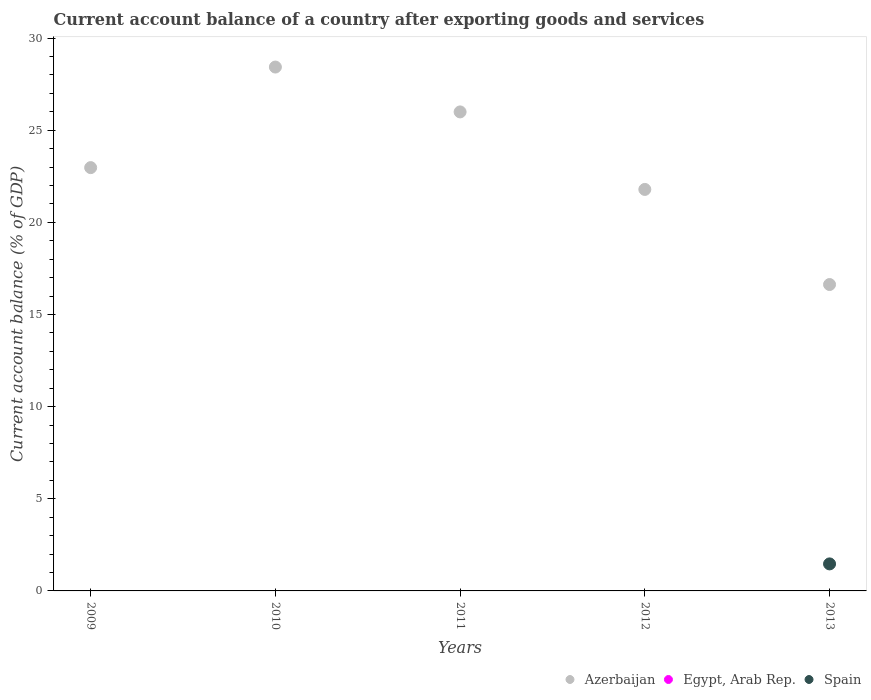What is the account balance in Egypt, Arab Rep. in 2009?
Offer a very short reply. 0. Across all years, what is the maximum account balance in Spain?
Ensure brevity in your answer.  1.47. In which year was the account balance in Spain maximum?
Keep it short and to the point. 2013. What is the total account balance in Spain in the graph?
Your answer should be very brief. 1.47. What is the difference between the account balance in Azerbaijan in 2011 and that in 2012?
Make the answer very short. 4.21. What is the average account balance in Azerbaijan per year?
Provide a succinct answer. 23.16. In the year 2013, what is the difference between the account balance in Spain and account balance in Azerbaijan?
Your answer should be compact. -15.16. In how many years, is the account balance in Egypt, Arab Rep. greater than 20 %?
Ensure brevity in your answer.  0. What is the ratio of the account balance in Azerbaijan in 2009 to that in 2010?
Provide a succinct answer. 0.81. What is the difference between the highest and the second highest account balance in Azerbaijan?
Provide a succinct answer. 2.43. What is the difference between the highest and the lowest account balance in Azerbaijan?
Your answer should be very brief. 11.8. In how many years, is the account balance in Azerbaijan greater than the average account balance in Azerbaijan taken over all years?
Offer a very short reply. 2. How many dotlines are there?
Your response must be concise. 2. How many years are there in the graph?
Offer a very short reply. 5. Are the values on the major ticks of Y-axis written in scientific E-notation?
Make the answer very short. No. Does the graph contain any zero values?
Ensure brevity in your answer.  Yes. Where does the legend appear in the graph?
Your answer should be very brief. Bottom right. How many legend labels are there?
Your answer should be compact. 3. What is the title of the graph?
Offer a very short reply. Current account balance of a country after exporting goods and services. Does "Belgium" appear as one of the legend labels in the graph?
Make the answer very short. No. What is the label or title of the X-axis?
Provide a short and direct response. Years. What is the label or title of the Y-axis?
Make the answer very short. Current account balance (% of GDP). What is the Current account balance (% of GDP) in Azerbaijan in 2009?
Your answer should be compact. 22.97. What is the Current account balance (% of GDP) of Spain in 2009?
Provide a succinct answer. 0. What is the Current account balance (% of GDP) in Azerbaijan in 2010?
Offer a terse response. 28.43. What is the Current account balance (% of GDP) of Azerbaijan in 2011?
Give a very brief answer. 26. What is the Current account balance (% of GDP) of Egypt, Arab Rep. in 2011?
Offer a very short reply. 0. What is the Current account balance (% of GDP) of Azerbaijan in 2012?
Give a very brief answer. 21.79. What is the Current account balance (% of GDP) of Azerbaijan in 2013?
Offer a very short reply. 16.63. What is the Current account balance (% of GDP) in Egypt, Arab Rep. in 2013?
Provide a short and direct response. 0. What is the Current account balance (% of GDP) in Spain in 2013?
Keep it short and to the point. 1.47. Across all years, what is the maximum Current account balance (% of GDP) in Azerbaijan?
Make the answer very short. 28.43. Across all years, what is the maximum Current account balance (% of GDP) in Spain?
Give a very brief answer. 1.47. Across all years, what is the minimum Current account balance (% of GDP) in Azerbaijan?
Your answer should be compact. 16.63. Across all years, what is the minimum Current account balance (% of GDP) of Spain?
Your answer should be very brief. 0. What is the total Current account balance (% of GDP) in Azerbaijan in the graph?
Your response must be concise. 115.82. What is the total Current account balance (% of GDP) in Egypt, Arab Rep. in the graph?
Your answer should be very brief. 0. What is the total Current account balance (% of GDP) of Spain in the graph?
Offer a terse response. 1.47. What is the difference between the Current account balance (% of GDP) of Azerbaijan in 2009 and that in 2010?
Offer a terse response. -5.46. What is the difference between the Current account balance (% of GDP) of Azerbaijan in 2009 and that in 2011?
Provide a succinct answer. -3.02. What is the difference between the Current account balance (% of GDP) of Azerbaijan in 2009 and that in 2012?
Provide a short and direct response. 1.18. What is the difference between the Current account balance (% of GDP) in Azerbaijan in 2009 and that in 2013?
Your response must be concise. 6.34. What is the difference between the Current account balance (% of GDP) of Azerbaijan in 2010 and that in 2011?
Your answer should be compact. 2.43. What is the difference between the Current account balance (% of GDP) in Azerbaijan in 2010 and that in 2012?
Offer a very short reply. 6.64. What is the difference between the Current account balance (% of GDP) in Azerbaijan in 2010 and that in 2013?
Make the answer very short. 11.8. What is the difference between the Current account balance (% of GDP) in Azerbaijan in 2011 and that in 2012?
Your answer should be very brief. 4.21. What is the difference between the Current account balance (% of GDP) of Azerbaijan in 2011 and that in 2013?
Your response must be concise. 9.37. What is the difference between the Current account balance (% of GDP) in Azerbaijan in 2012 and that in 2013?
Make the answer very short. 5.16. What is the difference between the Current account balance (% of GDP) of Azerbaijan in 2009 and the Current account balance (% of GDP) of Spain in 2013?
Ensure brevity in your answer.  21.51. What is the difference between the Current account balance (% of GDP) in Azerbaijan in 2010 and the Current account balance (% of GDP) in Spain in 2013?
Offer a terse response. 26.96. What is the difference between the Current account balance (% of GDP) of Azerbaijan in 2011 and the Current account balance (% of GDP) of Spain in 2013?
Ensure brevity in your answer.  24.53. What is the difference between the Current account balance (% of GDP) in Azerbaijan in 2012 and the Current account balance (% of GDP) in Spain in 2013?
Your answer should be compact. 20.32. What is the average Current account balance (% of GDP) of Azerbaijan per year?
Make the answer very short. 23.16. What is the average Current account balance (% of GDP) of Egypt, Arab Rep. per year?
Ensure brevity in your answer.  0. What is the average Current account balance (% of GDP) in Spain per year?
Your answer should be compact. 0.29. In the year 2013, what is the difference between the Current account balance (% of GDP) of Azerbaijan and Current account balance (% of GDP) of Spain?
Keep it short and to the point. 15.16. What is the ratio of the Current account balance (% of GDP) of Azerbaijan in 2009 to that in 2010?
Offer a very short reply. 0.81. What is the ratio of the Current account balance (% of GDP) of Azerbaijan in 2009 to that in 2011?
Make the answer very short. 0.88. What is the ratio of the Current account balance (% of GDP) in Azerbaijan in 2009 to that in 2012?
Offer a terse response. 1.05. What is the ratio of the Current account balance (% of GDP) of Azerbaijan in 2009 to that in 2013?
Offer a terse response. 1.38. What is the ratio of the Current account balance (% of GDP) in Azerbaijan in 2010 to that in 2011?
Offer a terse response. 1.09. What is the ratio of the Current account balance (% of GDP) in Azerbaijan in 2010 to that in 2012?
Offer a very short reply. 1.3. What is the ratio of the Current account balance (% of GDP) of Azerbaijan in 2010 to that in 2013?
Your response must be concise. 1.71. What is the ratio of the Current account balance (% of GDP) of Azerbaijan in 2011 to that in 2012?
Your answer should be compact. 1.19. What is the ratio of the Current account balance (% of GDP) of Azerbaijan in 2011 to that in 2013?
Give a very brief answer. 1.56. What is the ratio of the Current account balance (% of GDP) in Azerbaijan in 2012 to that in 2013?
Offer a very short reply. 1.31. What is the difference between the highest and the second highest Current account balance (% of GDP) of Azerbaijan?
Your answer should be very brief. 2.43. What is the difference between the highest and the lowest Current account balance (% of GDP) in Azerbaijan?
Your answer should be very brief. 11.8. What is the difference between the highest and the lowest Current account balance (% of GDP) of Spain?
Your answer should be very brief. 1.47. 